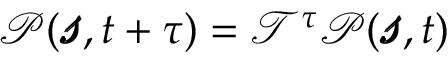<formula> <loc_0><loc_0><loc_500><loc_500>\begin{array} { r } { \mathcal { P } ( \pm b { \ m a t h s c r { s } } , t + \tau ) = \ m a t h s c r { T } ^ { \tau } \mathcal { P } ( \pm b { \ m a t h s c r { s } } , t ) } \end{array}</formula> 